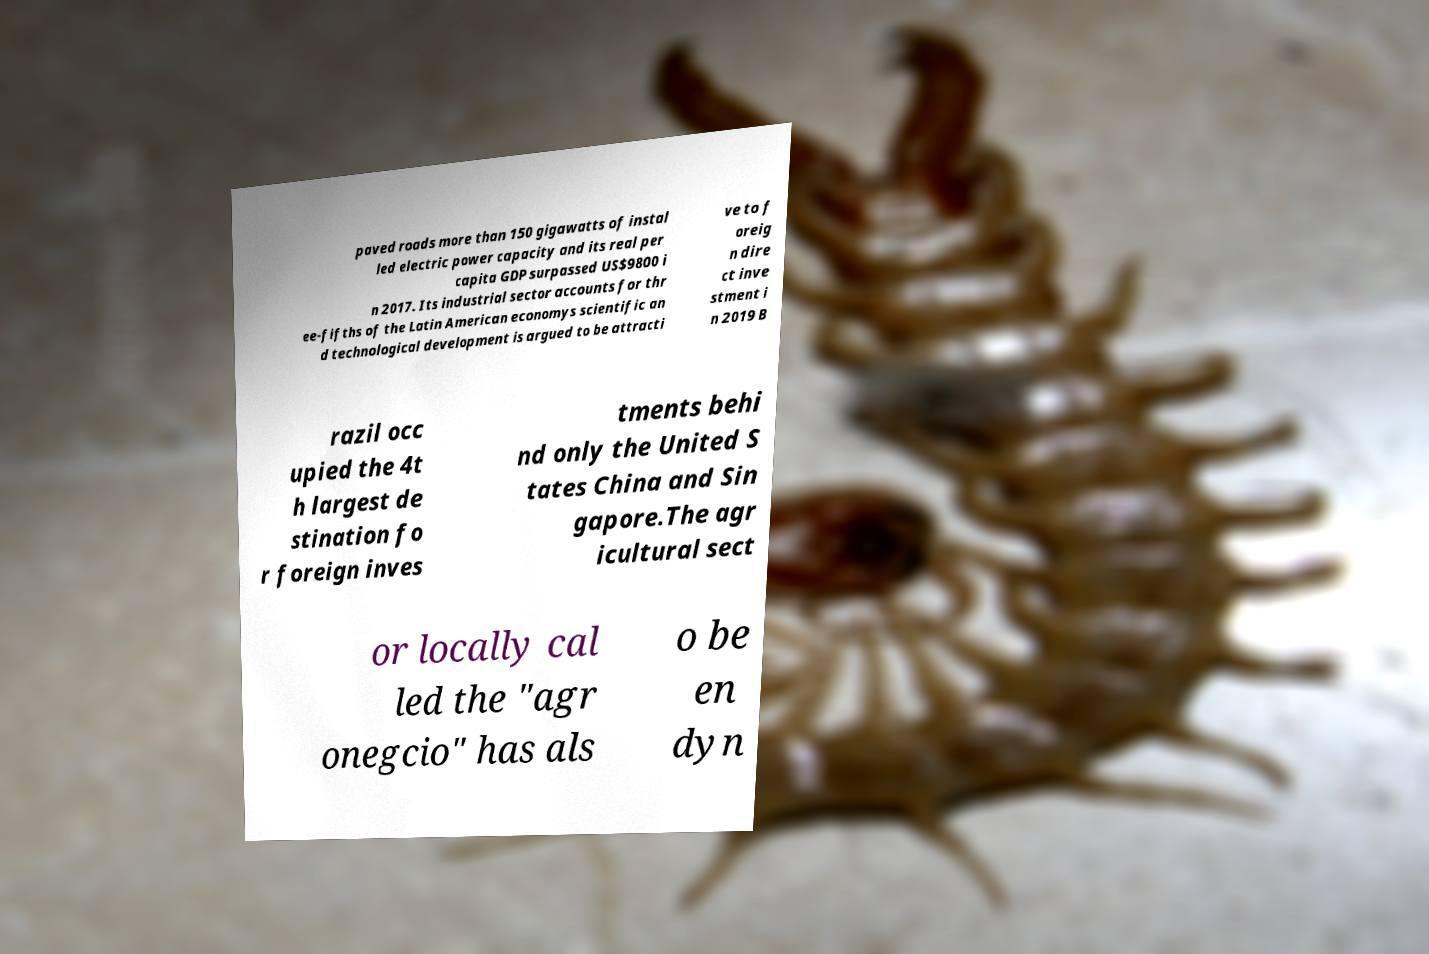For documentation purposes, I need the text within this image transcribed. Could you provide that? paved roads more than 150 gigawatts of instal led electric power capacity and its real per capita GDP surpassed US$9800 i n 2017. Its industrial sector accounts for thr ee-fifths of the Latin American economys scientific an d technological development is argued to be attracti ve to f oreig n dire ct inve stment i n 2019 B razil occ upied the 4t h largest de stination fo r foreign inves tments behi nd only the United S tates China and Sin gapore.The agr icultural sect or locally cal led the "agr onegcio" has als o be en dyn 